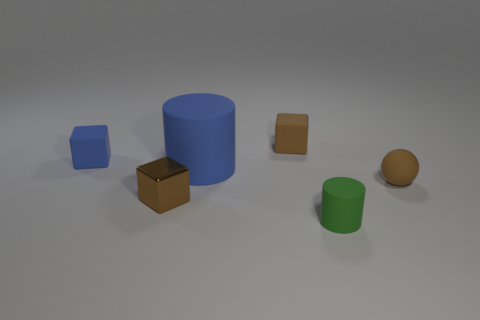Comparing the size, which is the largest object in the image? The blue cylinder is the largest object in the image in terms of height and volume. 